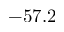<formula> <loc_0><loc_0><loc_500><loc_500>- 5 7 . 2</formula> 